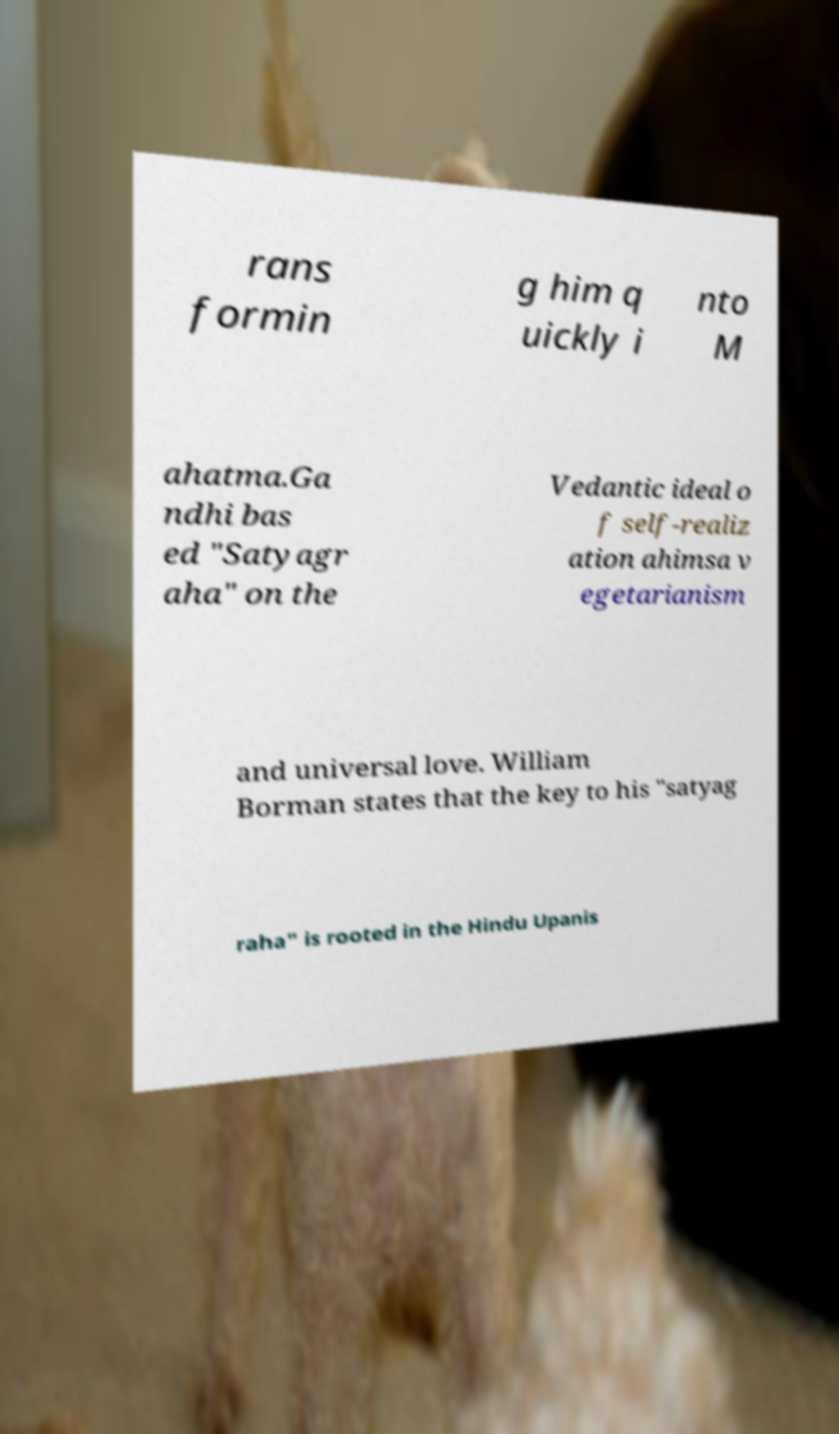Could you extract and type out the text from this image? rans formin g him q uickly i nto M ahatma.Ga ndhi bas ed "Satyagr aha" on the Vedantic ideal o f self-realiz ation ahimsa v egetarianism and universal love. William Borman states that the key to his "satyag raha" is rooted in the Hindu Upanis 